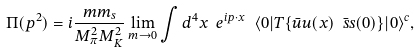Convert formula to latex. <formula><loc_0><loc_0><loc_500><loc_500>\Pi ( p ^ { 2 } ) = i \frac { m m _ { s } } { M ^ { 2 } _ { \pi } M ^ { 2 } _ { K } } \lim _ { m \to 0 } \int d ^ { 4 } x \ e ^ { i p \cdot x } \ \langle 0 | T \{ \bar { u } u ( x ) \ \bar { s } s ( 0 ) \} | 0 \rangle ^ { c } ,</formula> 